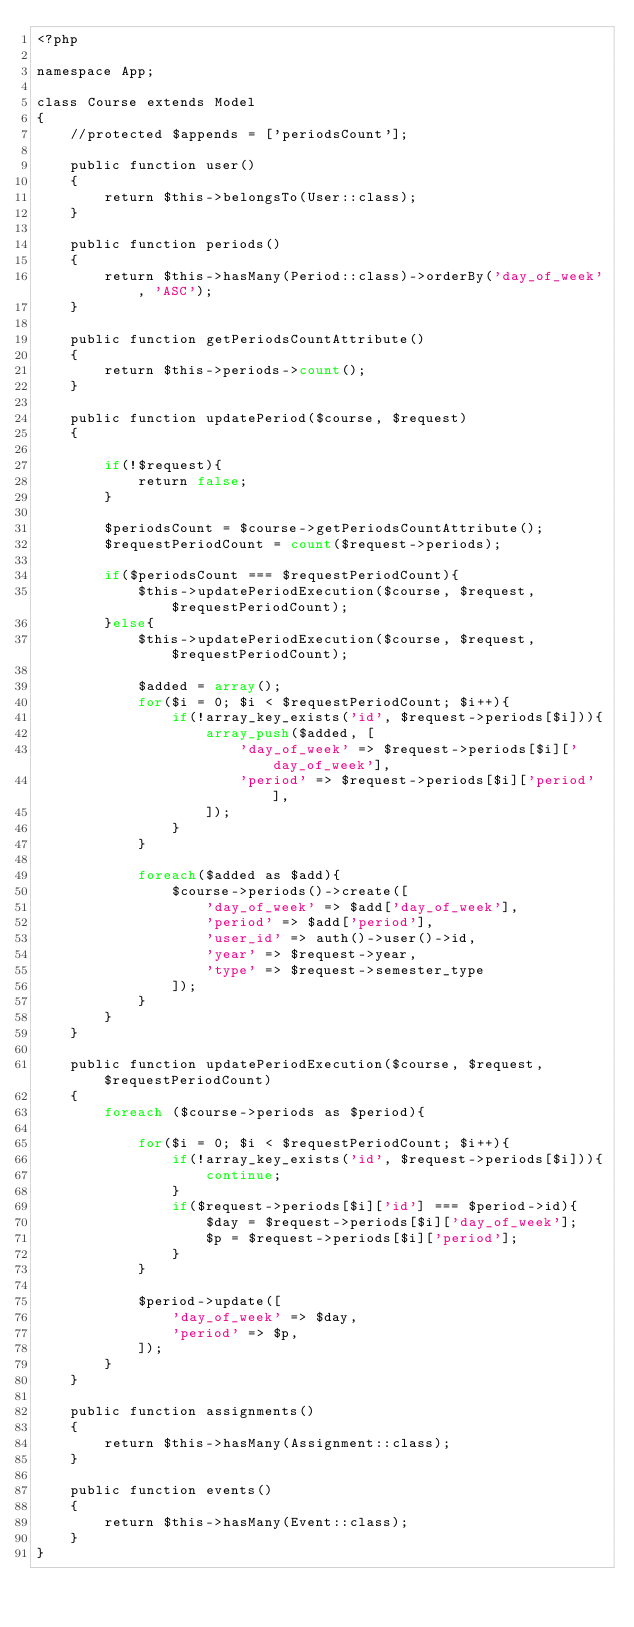<code> <loc_0><loc_0><loc_500><loc_500><_PHP_><?php

namespace App;

class Course extends Model
{
    //protected $appends = ['periodsCount'];

    public function user()
    {
        return $this->belongsTo(User::class);
    }

    public function periods()
    {
        return $this->hasMany(Period::class)->orderBy('day_of_week', 'ASC');
    }

    public function getPeriodsCountAttribute()
    {
        return $this->periods->count();
    }

    public function updatePeriod($course, $request)
    {

        if(!$request){
            return false;
        }
        
        $periodsCount = $course->getPeriodsCountAttribute();
        $requestPeriodCount = count($request->periods);

        if($periodsCount === $requestPeriodCount){
            $this->updatePeriodExecution($course, $request, $requestPeriodCount);
        }else{
            $this->updatePeriodExecution($course, $request, $requestPeriodCount);

            $added = array();
            for($i = 0; $i < $requestPeriodCount; $i++){
                if(!array_key_exists('id', $request->periods[$i])){
                    array_push($added, [
                        'day_of_week' => $request->periods[$i]['day_of_week'],
                        'period' => $request->periods[$i]['period'],
                    ]);
                }
            }
            
            foreach($added as $add){
                $course->periods()->create([
                    'day_of_week' => $add['day_of_week'],
                    'period' => $add['period'],
                    'user_id' => auth()->user()->id,
                    'year' => $request->year,
                    'type' => $request->semester_type
                ]);
            }
        }
    }

    public function updatePeriodExecution($course, $request, $requestPeriodCount)
    {
        foreach ($course->periods as $period){

            for($i = 0; $i < $requestPeriodCount; $i++){
                if(!array_key_exists('id', $request->periods[$i])){
                    continue;
                }
                if($request->periods[$i]['id'] === $period->id){
                    $day = $request->periods[$i]['day_of_week'];
                    $p = $request->periods[$i]['period'];
                }
            }
            
            $period->update([
                'day_of_week' => $day,
                'period' => $p,
            ]);
        }
    }

    public function assignments()
    {
        return $this->hasMany(Assignment::class);
    }

    public function events()
    {
        return $this->hasMany(Event::class);
    }
}
</code> 